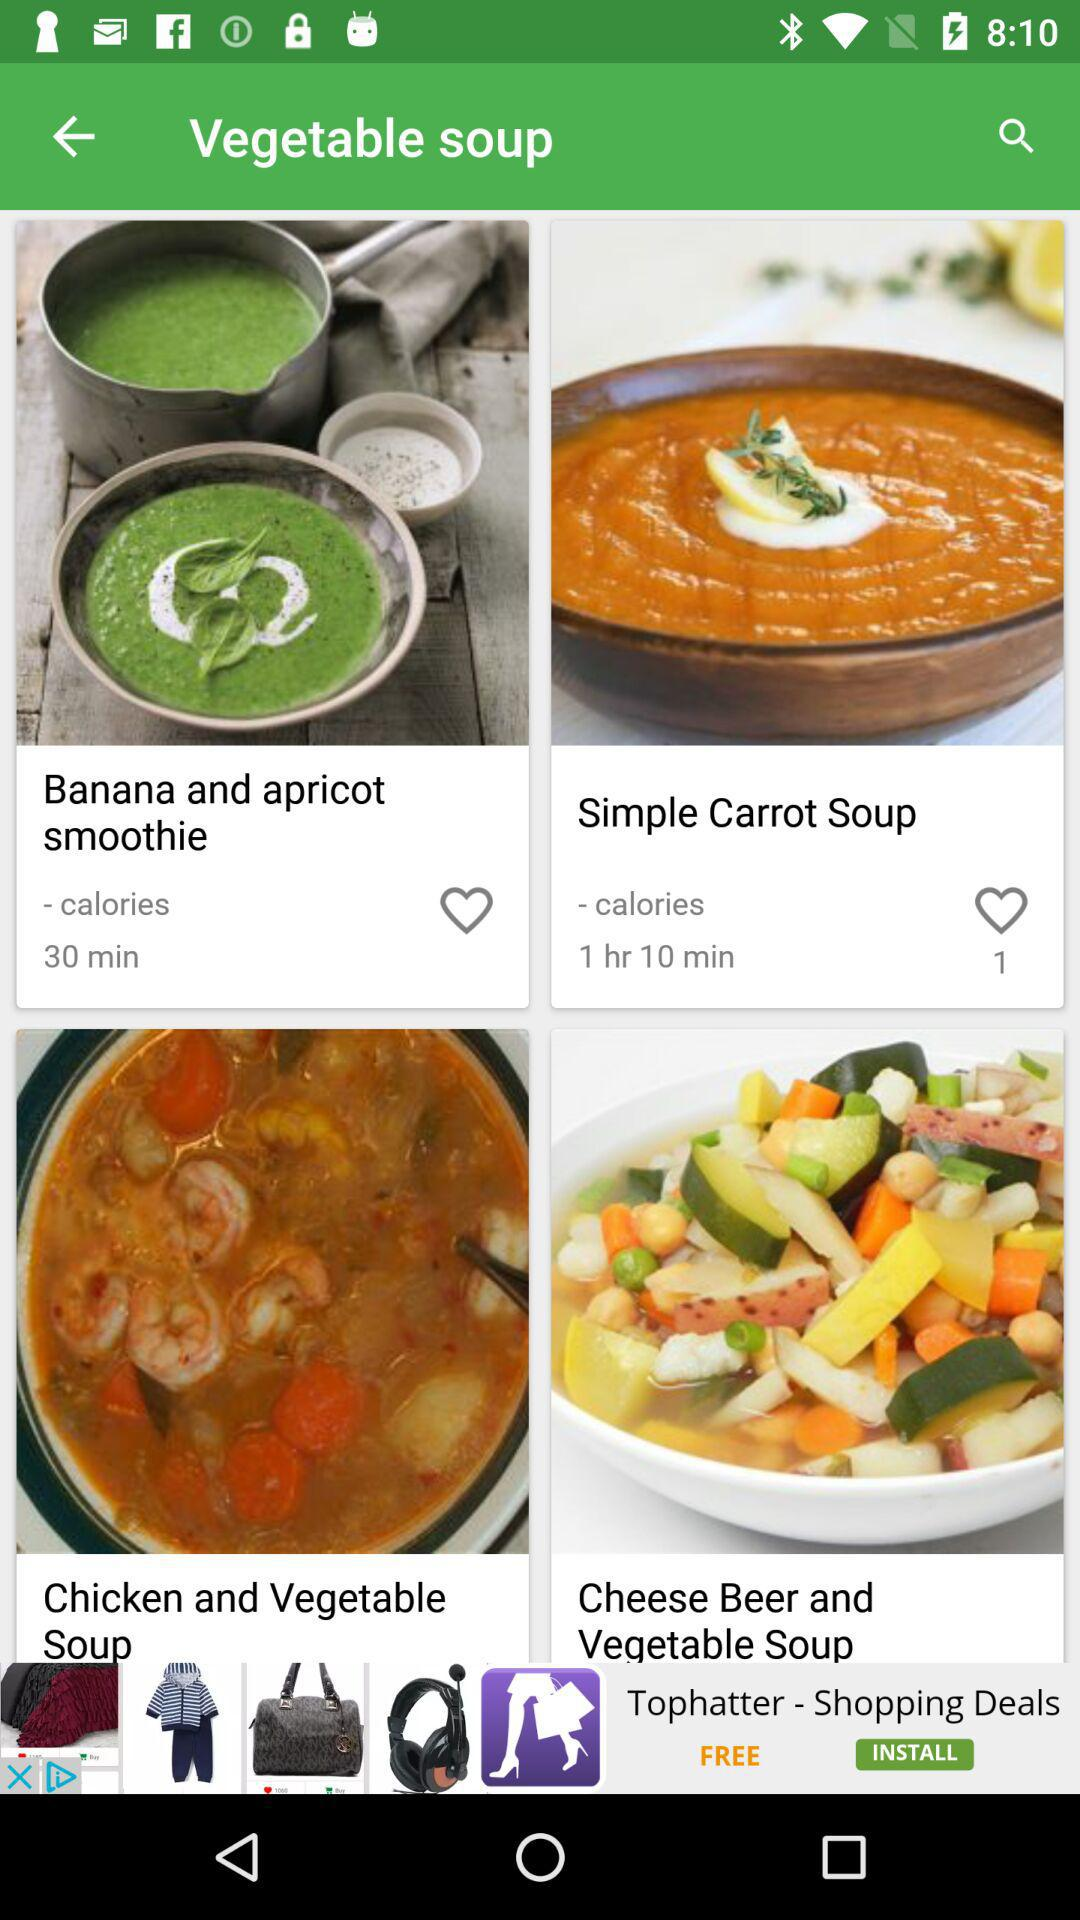How much time will it take to make the simple carrot soup?
When the provided information is insufficient, respond with <no answer>. <no answer> 